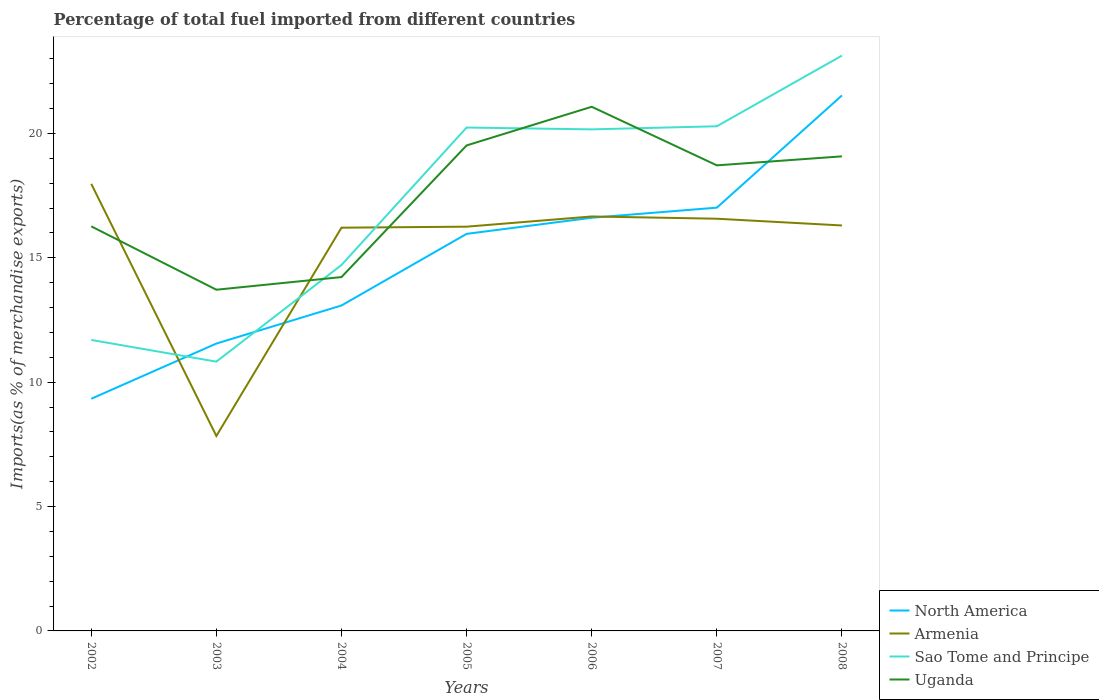How many different coloured lines are there?
Your response must be concise. 4. Does the line corresponding to Uganda intersect with the line corresponding to North America?
Offer a very short reply. Yes. Is the number of lines equal to the number of legend labels?
Ensure brevity in your answer.  Yes. Across all years, what is the maximum percentage of imports to different countries in Armenia?
Give a very brief answer. 7.84. What is the total percentage of imports to different countries in Uganda in the graph?
Provide a short and direct response. -1.55. What is the difference between the highest and the second highest percentage of imports to different countries in Armenia?
Provide a succinct answer. 10.14. What is the difference between the highest and the lowest percentage of imports to different countries in Uganda?
Your answer should be very brief. 4. Is the percentage of imports to different countries in Sao Tome and Principe strictly greater than the percentage of imports to different countries in Armenia over the years?
Offer a very short reply. No. How many lines are there?
Offer a very short reply. 4. How many years are there in the graph?
Keep it short and to the point. 7. Where does the legend appear in the graph?
Ensure brevity in your answer.  Bottom right. How are the legend labels stacked?
Ensure brevity in your answer.  Vertical. What is the title of the graph?
Your answer should be very brief. Percentage of total fuel imported from different countries. Does "Ethiopia" appear as one of the legend labels in the graph?
Your answer should be compact. No. What is the label or title of the Y-axis?
Provide a succinct answer. Imports(as % of merchandise exports). What is the Imports(as % of merchandise exports) in North America in 2002?
Provide a short and direct response. 9.33. What is the Imports(as % of merchandise exports) in Armenia in 2002?
Your response must be concise. 17.98. What is the Imports(as % of merchandise exports) in Sao Tome and Principe in 2002?
Ensure brevity in your answer.  11.7. What is the Imports(as % of merchandise exports) in Uganda in 2002?
Offer a terse response. 16.27. What is the Imports(as % of merchandise exports) in North America in 2003?
Offer a very short reply. 11.55. What is the Imports(as % of merchandise exports) of Armenia in 2003?
Your answer should be very brief. 7.84. What is the Imports(as % of merchandise exports) of Sao Tome and Principe in 2003?
Keep it short and to the point. 10.83. What is the Imports(as % of merchandise exports) in Uganda in 2003?
Offer a very short reply. 13.72. What is the Imports(as % of merchandise exports) in North America in 2004?
Provide a succinct answer. 13.08. What is the Imports(as % of merchandise exports) in Armenia in 2004?
Keep it short and to the point. 16.21. What is the Imports(as % of merchandise exports) of Sao Tome and Principe in 2004?
Make the answer very short. 14.71. What is the Imports(as % of merchandise exports) of Uganda in 2004?
Provide a short and direct response. 14.23. What is the Imports(as % of merchandise exports) of North America in 2005?
Keep it short and to the point. 15.96. What is the Imports(as % of merchandise exports) of Armenia in 2005?
Your answer should be compact. 16.25. What is the Imports(as % of merchandise exports) in Sao Tome and Principe in 2005?
Your response must be concise. 20.24. What is the Imports(as % of merchandise exports) of Uganda in 2005?
Your answer should be compact. 19.52. What is the Imports(as % of merchandise exports) of North America in 2006?
Give a very brief answer. 16.61. What is the Imports(as % of merchandise exports) of Armenia in 2006?
Offer a very short reply. 16.66. What is the Imports(as % of merchandise exports) in Sao Tome and Principe in 2006?
Your response must be concise. 20.17. What is the Imports(as % of merchandise exports) in Uganda in 2006?
Your answer should be compact. 21.07. What is the Imports(as % of merchandise exports) in North America in 2007?
Offer a terse response. 17.02. What is the Imports(as % of merchandise exports) in Armenia in 2007?
Keep it short and to the point. 16.57. What is the Imports(as % of merchandise exports) of Sao Tome and Principe in 2007?
Your answer should be compact. 20.29. What is the Imports(as % of merchandise exports) in Uganda in 2007?
Keep it short and to the point. 18.72. What is the Imports(as % of merchandise exports) in North America in 2008?
Make the answer very short. 21.53. What is the Imports(as % of merchandise exports) of Armenia in 2008?
Offer a very short reply. 16.3. What is the Imports(as % of merchandise exports) of Sao Tome and Principe in 2008?
Keep it short and to the point. 23.13. What is the Imports(as % of merchandise exports) in Uganda in 2008?
Give a very brief answer. 19.08. Across all years, what is the maximum Imports(as % of merchandise exports) of North America?
Keep it short and to the point. 21.53. Across all years, what is the maximum Imports(as % of merchandise exports) in Armenia?
Provide a succinct answer. 17.98. Across all years, what is the maximum Imports(as % of merchandise exports) of Sao Tome and Principe?
Offer a very short reply. 23.13. Across all years, what is the maximum Imports(as % of merchandise exports) in Uganda?
Make the answer very short. 21.07. Across all years, what is the minimum Imports(as % of merchandise exports) in North America?
Your answer should be compact. 9.33. Across all years, what is the minimum Imports(as % of merchandise exports) of Armenia?
Your answer should be compact. 7.84. Across all years, what is the minimum Imports(as % of merchandise exports) of Sao Tome and Principe?
Give a very brief answer. 10.83. Across all years, what is the minimum Imports(as % of merchandise exports) in Uganda?
Offer a terse response. 13.72. What is the total Imports(as % of merchandise exports) of North America in the graph?
Keep it short and to the point. 105.1. What is the total Imports(as % of merchandise exports) in Armenia in the graph?
Keep it short and to the point. 107.82. What is the total Imports(as % of merchandise exports) of Sao Tome and Principe in the graph?
Provide a succinct answer. 121.07. What is the total Imports(as % of merchandise exports) of Uganda in the graph?
Your answer should be very brief. 122.61. What is the difference between the Imports(as % of merchandise exports) of North America in 2002 and that in 2003?
Offer a very short reply. -2.22. What is the difference between the Imports(as % of merchandise exports) in Armenia in 2002 and that in 2003?
Provide a short and direct response. 10.14. What is the difference between the Imports(as % of merchandise exports) in Sao Tome and Principe in 2002 and that in 2003?
Keep it short and to the point. 0.87. What is the difference between the Imports(as % of merchandise exports) of Uganda in 2002 and that in 2003?
Provide a short and direct response. 2.55. What is the difference between the Imports(as % of merchandise exports) in North America in 2002 and that in 2004?
Make the answer very short. -3.75. What is the difference between the Imports(as % of merchandise exports) in Armenia in 2002 and that in 2004?
Your answer should be compact. 1.76. What is the difference between the Imports(as % of merchandise exports) in Sao Tome and Principe in 2002 and that in 2004?
Provide a succinct answer. -3.01. What is the difference between the Imports(as % of merchandise exports) of Uganda in 2002 and that in 2004?
Your answer should be very brief. 2.04. What is the difference between the Imports(as % of merchandise exports) of North America in 2002 and that in 2005?
Give a very brief answer. -6.63. What is the difference between the Imports(as % of merchandise exports) of Armenia in 2002 and that in 2005?
Give a very brief answer. 1.72. What is the difference between the Imports(as % of merchandise exports) of Sao Tome and Principe in 2002 and that in 2005?
Offer a very short reply. -8.54. What is the difference between the Imports(as % of merchandise exports) of Uganda in 2002 and that in 2005?
Your answer should be compact. -3.25. What is the difference between the Imports(as % of merchandise exports) in North America in 2002 and that in 2006?
Your response must be concise. -7.28. What is the difference between the Imports(as % of merchandise exports) in Armenia in 2002 and that in 2006?
Your response must be concise. 1.31. What is the difference between the Imports(as % of merchandise exports) in Sao Tome and Principe in 2002 and that in 2006?
Ensure brevity in your answer.  -8.47. What is the difference between the Imports(as % of merchandise exports) of Uganda in 2002 and that in 2006?
Give a very brief answer. -4.81. What is the difference between the Imports(as % of merchandise exports) in North America in 2002 and that in 2007?
Your answer should be compact. -7.68. What is the difference between the Imports(as % of merchandise exports) of Armenia in 2002 and that in 2007?
Keep it short and to the point. 1.4. What is the difference between the Imports(as % of merchandise exports) in Sao Tome and Principe in 2002 and that in 2007?
Offer a terse response. -8.59. What is the difference between the Imports(as % of merchandise exports) in Uganda in 2002 and that in 2007?
Your answer should be compact. -2.45. What is the difference between the Imports(as % of merchandise exports) of North America in 2002 and that in 2008?
Offer a very short reply. -12.2. What is the difference between the Imports(as % of merchandise exports) in Armenia in 2002 and that in 2008?
Offer a terse response. 1.67. What is the difference between the Imports(as % of merchandise exports) in Sao Tome and Principe in 2002 and that in 2008?
Keep it short and to the point. -11.43. What is the difference between the Imports(as % of merchandise exports) in Uganda in 2002 and that in 2008?
Your response must be concise. -2.81. What is the difference between the Imports(as % of merchandise exports) of North America in 2003 and that in 2004?
Offer a very short reply. -1.53. What is the difference between the Imports(as % of merchandise exports) of Armenia in 2003 and that in 2004?
Give a very brief answer. -8.37. What is the difference between the Imports(as % of merchandise exports) of Sao Tome and Principe in 2003 and that in 2004?
Give a very brief answer. -3.89. What is the difference between the Imports(as % of merchandise exports) in Uganda in 2003 and that in 2004?
Your answer should be compact. -0.51. What is the difference between the Imports(as % of merchandise exports) of North America in 2003 and that in 2005?
Provide a succinct answer. -4.41. What is the difference between the Imports(as % of merchandise exports) in Armenia in 2003 and that in 2005?
Give a very brief answer. -8.41. What is the difference between the Imports(as % of merchandise exports) in Sao Tome and Principe in 2003 and that in 2005?
Your response must be concise. -9.41. What is the difference between the Imports(as % of merchandise exports) of Uganda in 2003 and that in 2005?
Offer a very short reply. -5.8. What is the difference between the Imports(as % of merchandise exports) of North America in 2003 and that in 2006?
Provide a short and direct response. -5.06. What is the difference between the Imports(as % of merchandise exports) in Armenia in 2003 and that in 2006?
Your answer should be compact. -8.83. What is the difference between the Imports(as % of merchandise exports) of Sao Tome and Principe in 2003 and that in 2006?
Make the answer very short. -9.34. What is the difference between the Imports(as % of merchandise exports) of Uganda in 2003 and that in 2006?
Make the answer very short. -7.36. What is the difference between the Imports(as % of merchandise exports) in North America in 2003 and that in 2007?
Provide a succinct answer. -5.46. What is the difference between the Imports(as % of merchandise exports) in Armenia in 2003 and that in 2007?
Your answer should be compact. -8.73. What is the difference between the Imports(as % of merchandise exports) in Sao Tome and Principe in 2003 and that in 2007?
Ensure brevity in your answer.  -9.46. What is the difference between the Imports(as % of merchandise exports) of Uganda in 2003 and that in 2007?
Offer a terse response. -5. What is the difference between the Imports(as % of merchandise exports) of North America in 2003 and that in 2008?
Give a very brief answer. -9.98. What is the difference between the Imports(as % of merchandise exports) of Armenia in 2003 and that in 2008?
Provide a succinct answer. -8.46. What is the difference between the Imports(as % of merchandise exports) of Sao Tome and Principe in 2003 and that in 2008?
Your answer should be very brief. -12.31. What is the difference between the Imports(as % of merchandise exports) of Uganda in 2003 and that in 2008?
Provide a succinct answer. -5.36. What is the difference between the Imports(as % of merchandise exports) of North America in 2004 and that in 2005?
Keep it short and to the point. -2.88. What is the difference between the Imports(as % of merchandise exports) in Armenia in 2004 and that in 2005?
Ensure brevity in your answer.  -0.04. What is the difference between the Imports(as % of merchandise exports) in Sao Tome and Principe in 2004 and that in 2005?
Offer a terse response. -5.53. What is the difference between the Imports(as % of merchandise exports) in Uganda in 2004 and that in 2005?
Make the answer very short. -5.29. What is the difference between the Imports(as % of merchandise exports) of North America in 2004 and that in 2006?
Provide a succinct answer. -3.53. What is the difference between the Imports(as % of merchandise exports) of Armenia in 2004 and that in 2006?
Offer a terse response. -0.45. What is the difference between the Imports(as % of merchandise exports) of Sao Tome and Principe in 2004 and that in 2006?
Make the answer very short. -5.45. What is the difference between the Imports(as % of merchandise exports) of Uganda in 2004 and that in 2006?
Offer a very short reply. -6.85. What is the difference between the Imports(as % of merchandise exports) in North America in 2004 and that in 2007?
Provide a short and direct response. -3.93. What is the difference between the Imports(as % of merchandise exports) in Armenia in 2004 and that in 2007?
Keep it short and to the point. -0.36. What is the difference between the Imports(as % of merchandise exports) of Sao Tome and Principe in 2004 and that in 2007?
Keep it short and to the point. -5.58. What is the difference between the Imports(as % of merchandise exports) in Uganda in 2004 and that in 2007?
Your response must be concise. -4.49. What is the difference between the Imports(as % of merchandise exports) of North America in 2004 and that in 2008?
Give a very brief answer. -8.45. What is the difference between the Imports(as % of merchandise exports) in Armenia in 2004 and that in 2008?
Your answer should be compact. -0.09. What is the difference between the Imports(as % of merchandise exports) in Sao Tome and Principe in 2004 and that in 2008?
Provide a succinct answer. -8.42. What is the difference between the Imports(as % of merchandise exports) of Uganda in 2004 and that in 2008?
Give a very brief answer. -4.85. What is the difference between the Imports(as % of merchandise exports) of North America in 2005 and that in 2006?
Your answer should be very brief. -0.65. What is the difference between the Imports(as % of merchandise exports) of Armenia in 2005 and that in 2006?
Provide a short and direct response. -0.41. What is the difference between the Imports(as % of merchandise exports) of Sao Tome and Principe in 2005 and that in 2006?
Provide a short and direct response. 0.07. What is the difference between the Imports(as % of merchandise exports) in Uganda in 2005 and that in 2006?
Offer a very short reply. -1.55. What is the difference between the Imports(as % of merchandise exports) in North America in 2005 and that in 2007?
Make the answer very short. -1.05. What is the difference between the Imports(as % of merchandise exports) in Armenia in 2005 and that in 2007?
Your answer should be very brief. -0.32. What is the difference between the Imports(as % of merchandise exports) of Sao Tome and Principe in 2005 and that in 2007?
Provide a succinct answer. -0.05. What is the difference between the Imports(as % of merchandise exports) of Uganda in 2005 and that in 2007?
Provide a succinct answer. 0.8. What is the difference between the Imports(as % of merchandise exports) of North America in 2005 and that in 2008?
Give a very brief answer. -5.57. What is the difference between the Imports(as % of merchandise exports) in Armenia in 2005 and that in 2008?
Your answer should be very brief. -0.05. What is the difference between the Imports(as % of merchandise exports) in Sao Tome and Principe in 2005 and that in 2008?
Keep it short and to the point. -2.89. What is the difference between the Imports(as % of merchandise exports) in Uganda in 2005 and that in 2008?
Offer a terse response. 0.44. What is the difference between the Imports(as % of merchandise exports) of North America in 2006 and that in 2007?
Offer a very short reply. -0.41. What is the difference between the Imports(as % of merchandise exports) of Armenia in 2006 and that in 2007?
Provide a short and direct response. 0.09. What is the difference between the Imports(as % of merchandise exports) in Sao Tome and Principe in 2006 and that in 2007?
Your answer should be compact. -0.12. What is the difference between the Imports(as % of merchandise exports) of Uganda in 2006 and that in 2007?
Your answer should be very brief. 2.36. What is the difference between the Imports(as % of merchandise exports) in North America in 2006 and that in 2008?
Give a very brief answer. -4.92. What is the difference between the Imports(as % of merchandise exports) in Armenia in 2006 and that in 2008?
Provide a short and direct response. 0.36. What is the difference between the Imports(as % of merchandise exports) in Sao Tome and Principe in 2006 and that in 2008?
Give a very brief answer. -2.97. What is the difference between the Imports(as % of merchandise exports) of Uganda in 2006 and that in 2008?
Make the answer very short. 1.99. What is the difference between the Imports(as % of merchandise exports) of North America in 2007 and that in 2008?
Your answer should be very brief. -4.51. What is the difference between the Imports(as % of merchandise exports) of Armenia in 2007 and that in 2008?
Your answer should be compact. 0.27. What is the difference between the Imports(as % of merchandise exports) of Sao Tome and Principe in 2007 and that in 2008?
Ensure brevity in your answer.  -2.84. What is the difference between the Imports(as % of merchandise exports) of Uganda in 2007 and that in 2008?
Offer a terse response. -0.36. What is the difference between the Imports(as % of merchandise exports) of North America in 2002 and the Imports(as % of merchandise exports) of Armenia in 2003?
Provide a succinct answer. 1.5. What is the difference between the Imports(as % of merchandise exports) in North America in 2002 and the Imports(as % of merchandise exports) in Sao Tome and Principe in 2003?
Ensure brevity in your answer.  -1.49. What is the difference between the Imports(as % of merchandise exports) in North America in 2002 and the Imports(as % of merchandise exports) in Uganda in 2003?
Offer a terse response. -4.38. What is the difference between the Imports(as % of merchandise exports) of Armenia in 2002 and the Imports(as % of merchandise exports) of Sao Tome and Principe in 2003?
Offer a very short reply. 7.15. What is the difference between the Imports(as % of merchandise exports) in Armenia in 2002 and the Imports(as % of merchandise exports) in Uganda in 2003?
Make the answer very short. 4.26. What is the difference between the Imports(as % of merchandise exports) in Sao Tome and Principe in 2002 and the Imports(as % of merchandise exports) in Uganda in 2003?
Make the answer very short. -2.02. What is the difference between the Imports(as % of merchandise exports) in North America in 2002 and the Imports(as % of merchandise exports) in Armenia in 2004?
Make the answer very short. -6.88. What is the difference between the Imports(as % of merchandise exports) in North America in 2002 and the Imports(as % of merchandise exports) in Sao Tome and Principe in 2004?
Your response must be concise. -5.38. What is the difference between the Imports(as % of merchandise exports) of North America in 2002 and the Imports(as % of merchandise exports) of Uganda in 2004?
Provide a short and direct response. -4.89. What is the difference between the Imports(as % of merchandise exports) in Armenia in 2002 and the Imports(as % of merchandise exports) in Sao Tome and Principe in 2004?
Offer a very short reply. 3.26. What is the difference between the Imports(as % of merchandise exports) in Armenia in 2002 and the Imports(as % of merchandise exports) in Uganda in 2004?
Your answer should be very brief. 3.75. What is the difference between the Imports(as % of merchandise exports) in Sao Tome and Principe in 2002 and the Imports(as % of merchandise exports) in Uganda in 2004?
Keep it short and to the point. -2.53. What is the difference between the Imports(as % of merchandise exports) in North America in 2002 and the Imports(as % of merchandise exports) in Armenia in 2005?
Your answer should be compact. -6.92. What is the difference between the Imports(as % of merchandise exports) of North America in 2002 and the Imports(as % of merchandise exports) of Sao Tome and Principe in 2005?
Your response must be concise. -10.91. What is the difference between the Imports(as % of merchandise exports) of North America in 2002 and the Imports(as % of merchandise exports) of Uganda in 2005?
Offer a terse response. -10.19. What is the difference between the Imports(as % of merchandise exports) of Armenia in 2002 and the Imports(as % of merchandise exports) of Sao Tome and Principe in 2005?
Provide a short and direct response. -2.26. What is the difference between the Imports(as % of merchandise exports) in Armenia in 2002 and the Imports(as % of merchandise exports) in Uganda in 2005?
Ensure brevity in your answer.  -1.54. What is the difference between the Imports(as % of merchandise exports) of Sao Tome and Principe in 2002 and the Imports(as % of merchandise exports) of Uganda in 2005?
Provide a succinct answer. -7.82. What is the difference between the Imports(as % of merchandise exports) of North America in 2002 and the Imports(as % of merchandise exports) of Armenia in 2006?
Give a very brief answer. -7.33. What is the difference between the Imports(as % of merchandise exports) in North America in 2002 and the Imports(as % of merchandise exports) in Sao Tome and Principe in 2006?
Your answer should be compact. -10.83. What is the difference between the Imports(as % of merchandise exports) of North America in 2002 and the Imports(as % of merchandise exports) of Uganda in 2006?
Your answer should be compact. -11.74. What is the difference between the Imports(as % of merchandise exports) in Armenia in 2002 and the Imports(as % of merchandise exports) in Sao Tome and Principe in 2006?
Offer a very short reply. -2.19. What is the difference between the Imports(as % of merchandise exports) in Armenia in 2002 and the Imports(as % of merchandise exports) in Uganda in 2006?
Offer a very short reply. -3.1. What is the difference between the Imports(as % of merchandise exports) of Sao Tome and Principe in 2002 and the Imports(as % of merchandise exports) of Uganda in 2006?
Provide a short and direct response. -9.38. What is the difference between the Imports(as % of merchandise exports) in North America in 2002 and the Imports(as % of merchandise exports) in Armenia in 2007?
Keep it short and to the point. -7.24. What is the difference between the Imports(as % of merchandise exports) of North America in 2002 and the Imports(as % of merchandise exports) of Sao Tome and Principe in 2007?
Make the answer very short. -10.96. What is the difference between the Imports(as % of merchandise exports) of North America in 2002 and the Imports(as % of merchandise exports) of Uganda in 2007?
Your answer should be very brief. -9.38. What is the difference between the Imports(as % of merchandise exports) of Armenia in 2002 and the Imports(as % of merchandise exports) of Sao Tome and Principe in 2007?
Ensure brevity in your answer.  -2.32. What is the difference between the Imports(as % of merchandise exports) in Armenia in 2002 and the Imports(as % of merchandise exports) in Uganda in 2007?
Offer a terse response. -0.74. What is the difference between the Imports(as % of merchandise exports) in Sao Tome and Principe in 2002 and the Imports(as % of merchandise exports) in Uganda in 2007?
Ensure brevity in your answer.  -7.02. What is the difference between the Imports(as % of merchandise exports) in North America in 2002 and the Imports(as % of merchandise exports) in Armenia in 2008?
Keep it short and to the point. -6.97. What is the difference between the Imports(as % of merchandise exports) in North America in 2002 and the Imports(as % of merchandise exports) in Sao Tome and Principe in 2008?
Ensure brevity in your answer.  -13.8. What is the difference between the Imports(as % of merchandise exports) of North America in 2002 and the Imports(as % of merchandise exports) of Uganda in 2008?
Give a very brief answer. -9.75. What is the difference between the Imports(as % of merchandise exports) of Armenia in 2002 and the Imports(as % of merchandise exports) of Sao Tome and Principe in 2008?
Offer a terse response. -5.16. What is the difference between the Imports(as % of merchandise exports) of Armenia in 2002 and the Imports(as % of merchandise exports) of Uganda in 2008?
Make the answer very short. -1.11. What is the difference between the Imports(as % of merchandise exports) in Sao Tome and Principe in 2002 and the Imports(as % of merchandise exports) in Uganda in 2008?
Your answer should be very brief. -7.38. What is the difference between the Imports(as % of merchandise exports) of North America in 2003 and the Imports(as % of merchandise exports) of Armenia in 2004?
Provide a succinct answer. -4.66. What is the difference between the Imports(as % of merchandise exports) of North America in 2003 and the Imports(as % of merchandise exports) of Sao Tome and Principe in 2004?
Keep it short and to the point. -3.16. What is the difference between the Imports(as % of merchandise exports) of North America in 2003 and the Imports(as % of merchandise exports) of Uganda in 2004?
Make the answer very short. -2.67. What is the difference between the Imports(as % of merchandise exports) of Armenia in 2003 and the Imports(as % of merchandise exports) of Sao Tome and Principe in 2004?
Ensure brevity in your answer.  -6.87. What is the difference between the Imports(as % of merchandise exports) in Armenia in 2003 and the Imports(as % of merchandise exports) in Uganda in 2004?
Your response must be concise. -6.39. What is the difference between the Imports(as % of merchandise exports) in Sao Tome and Principe in 2003 and the Imports(as % of merchandise exports) in Uganda in 2004?
Your response must be concise. -3.4. What is the difference between the Imports(as % of merchandise exports) of North America in 2003 and the Imports(as % of merchandise exports) of Armenia in 2005?
Provide a short and direct response. -4.7. What is the difference between the Imports(as % of merchandise exports) in North America in 2003 and the Imports(as % of merchandise exports) in Sao Tome and Principe in 2005?
Offer a very short reply. -8.69. What is the difference between the Imports(as % of merchandise exports) of North America in 2003 and the Imports(as % of merchandise exports) of Uganda in 2005?
Ensure brevity in your answer.  -7.97. What is the difference between the Imports(as % of merchandise exports) of Armenia in 2003 and the Imports(as % of merchandise exports) of Sao Tome and Principe in 2005?
Ensure brevity in your answer.  -12.4. What is the difference between the Imports(as % of merchandise exports) of Armenia in 2003 and the Imports(as % of merchandise exports) of Uganda in 2005?
Your answer should be compact. -11.68. What is the difference between the Imports(as % of merchandise exports) of Sao Tome and Principe in 2003 and the Imports(as % of merchandise exports) of Uganda in 2005?
Your answer should be very brief. -8.69. What is the difference between the Imports(as % of merchandise exports) of North America in 2003 and the Imports(as % of merchandise exports) of Armenia in 2006?
Ensure brevity in your answer.  -5.11. What is the difference between the Imports(as % of merchandise exports) of North America in 2003 and the Imports(as % of merchandise exports) of Sao Tome and Principe in 2006?
Ensure brevity in your answer.  -8.61. What is the difference between the Imports(as % of merchandise exports) in North America in 2003 and the Imports(as % of merchandise exports) in Uganda in 2006?
Provide a succinct answer. -9.52. What is the difference between the Imports(as % of merchandise exports) in Armenia in 2003 and the Imports(as % of merchandise exports) in Sao Tome and Principe in 2006?
Provide a succinct answer. -12.33. What is the difference between the Imports(as % of merchandise exports) in Armenia in 2003 and the Imports(as % of merchandise exports) in Uganda in 2006?
Keep it short and to the point. -13.24. What is the difference between the Imports(as % of merchandise exports) of Sao Tome and Principe in 2003 and the Imports(as % of merchandise exports) of Uganda in 2006?
Make the answer very short. -10.25. What is the difference between the Imports(as % of merchandise exports) of North America in 2003 and the Imports(as % of merchandise exports) of Armenia in 2007?
Provide a succinct answer. -5.02. What is the difference between the Imports(as % of merchandise exports) of North America in 2003 and the Imports(as % of merchandise exports) of Sao Tome and Principe in 2007?
Ensure brevity in your answer.  -8.74. What is the difference between the Imports(as % of merchandise exports) in North America in 2003 and the Imports(as % of merchandise exports) in Uganda in 2007?
Keep it short and to the point. -7.17. What is the difference between the Imports(as % of merchandise exports) in Armenia in 2003 and the Imports(as % of merchandise exports) in Sao Tome and Principe in 2007?
Your response must be concise. -12.45. What is the difference between the Imports(as % of merchandise exports) of Armenia in 2003 and the Imports(as % of merchandise exports) of Uganda in 2007?
Provide a short and direct response. -10.88. What is the difference between the Imports(as % of merchandise exports) of Sao Tome and Principe in 2003 and the Imports(as % of merchandise exports) of Uganda in 2007?
Your answer should be compact. -7.89. What is the difference between the Imports(as % of merchandise exports) in North America in 2003 and the Imports(as % of merchandise exports) in Armenia in 2008?
Keep it short and to the point. -4.75. What is the difference between the Imports(as % of merchandise exports) in North America in 2003 and the Imports(as % of merchandise exports) in Sao Tome and Principe in 2008?
Your answer should be compact. -11.58. What is the difference between the Imports(as % of merchandise exports) of North America in 2003 and the Imports(as % of merchandise exports) of Uganda in 2008?
Ensure brevity in your answer.  -7.53. What is the difference between the Imports(as % of merchandise exports) of Armenia in 2003 and the Imports(as % of merchandise exports) of Sao Tome and Principe in 2008?
Offer a terse response. -15.29. What is the difference between the Imports(as % of merchandise exports) in Armenia in 2003 and the Imports(as % of merchandise exports) in Uganda in 2008?
Make the answer very short. -11.24. What is the difference between the Imports(as % of merchandise exports) of Sao Tome and Principe in 2003 and the Imports(as % of merchandise exports) of Uganda in 2008?
Offer a terse response. -8.25. What is the difference between the Imports(as % of merchandise exports) in North America in 2004 and the Imports(as % of merchandise exports) in Armenia in 2005?
Provide a short and direct response. -3.17. What is the difference between the Imports(as % of merchandise exports) of North America in 2004 and the Imports(as % of merchandise exports) of Sao Tome and Principe in 2005?
Provide a succinct answer. -7.16. What is the difference between the Imports(as % of merchandise exports) in North America in 2004 and the Imports(as % of merchandise exports) in Uganda in 2005?
Your answer should be very brief. -6.44. What is the difference between the Imports(as % of merchandise exports) in Armenia in 2004 and the Imports(as % of merchandise exports) in Sao Tome and Principe in 2005?
Offer a terse response. -4.03. What is the difference between the Imports(as % of merchandise exports) of Armenia in 2004 and the Imports(as % of merchandise exports) of Uganda in 2005?
Your answer should be compact. -3.31. What is the difference between the Imports(as % of merchandise exports) in Sao Tome and Principe in 2004 and the Imports(as % of merchandise exports) in Uganda in 2005?
Give a very brief answer. -4.81. What is the difference between the Imports(as % of merchandise exports) in North America in 2004 and the Imports(as % of merchandise exports) in Armenia in 2006?
Your response must be concise. -3.58. What is the difference between the Imports(as % of merchandise exports) of North America in 2004 and the Imports(as % of merchandise exports) of Sao Tome and Principe in 2006?
Make the answer very short. -7.08. What is the difference between the Imports(as % of merchandise exports) of North America in 2004 and the Imports(as % of merchandise exports) of Uganda in 2006?
Offer a very short reply. -7.99. What is the difference between the Imports(as % of merchandise exports) in Armenia in 2004 and the Imports(as % of merchandise exports) in Sao Tome and Principe in 2006?
Ensure brevity in your answer.  -3.95. What is the difference between the Imports(as % of merchandise exports) of Armenia in 2004 and the Imports(as % of merchandise exports) of Uganda in 2006?
Ensure brevity in your answer.  -4.86. What is the difference between the Imports(as % of merchandise exports) of Sao Tome and Principe in 2004 and the Imports(as % of merchandise exports) of Uganda in 2006?
Offer a terse response. -6.36. What is the difference between the Imports(as % of merchandise exports) in North America in 2004 and the Imports(as % of merchandise exports) in Armenia in 2007?
Provide a succinct answer. -3.49. What is the difference between the Imports(as % of merchandise exports) of North America in 2004 and the Imports(as % of merchandise exports) of Sao Tome and Principe in 2007?
Keep it short and to the point. -7.21. What is the difference between the Imports(as % of merchandise exports) of North America in 2004 and the Imports(as % of merchandise exports) of Uganda in 2007?
Make the answer very short. -5.63. What is the difference between the Imports(as % of merchandise exports) of Armenia in 2004 and the Imports(as % of merchandise exports) of Sao Tome and Principe in 2007?
Your answer should be very brief. -4.08. What is the difference between the Imports(as % of merchandise exports) of Armenia in 2004 and the Imports(as % of merchandise exports) of Uganda in 2007?
Your answer should be very brief. -2.51. What is the difference between the Imports(as % of merchandise exports) in Sao Tome and Principe in 2004 and the Imports(as % of merchandise exports) in Uganda in 2007?
Your response must be concise. -4.01. What is the difference between the Imports(as % of merchandise exports) of North America in 2004 and the Imports(as % of merchandise exports) of Armenia in 2008?
Offer a terse response. -3.22. What is the difference between the Imports(as % of merchandise exports) in North America in 2004 and the Imports(as % of merchandise exports) in Sao Tome and Principe in 2008?
Provide a short and direct response. -10.05. What is the difference between the Imports(as % of merchandise exports) of North America in 2004 and the Imports(as % of merchandise exports) of Uganda in 2008?
Your answer should be very brief. -6. What is the difference between the Imports(as % of merchandise exports) of Armenia in 2004 and the Imports(as % of merchandise exports) of Sao Tome and Principe in 2008?
Provide a short and direct response. -6.92. What is the difference between the Imports(as % of merchandise exports) in Armenia in 2004 and the Imports(as % of merchandise exports) in Uganda in 2008?
Your response must be concise. -2.87. What is the difference between the Imports(as % of merchandise exports) of Sao Tome and Principe in 2004 and the Imports(as % of merchandise exports) of Uganda in 2008?
Provide a succinct answer. -4.37. What is the difference between the Imports(as % of merchandise exports) in North America in 2005 and the Imports(as % of merchandise exports) in Armenia in 2006?
Your answer should be very brief. -0.7. What is the difference between the Imports(as % of merchandise exports) in North America in 2005 and the Imports(as % of merchandise exports) in Sao Tome and Principe in 2006?
Provide a short and direct response. -4.2. What is the difference between the Imports(as % of merchandise exports) of North America in 2005 and the Imports(as % of merchandise exports) of Uganda in 2006?
Offer a terse response. -5.11. What is the difference between the Imports(as % of merchandise exports) of Armenia in 2005 and the Imports(as % of merchandise exports) of Sao Tome and Principe in 2006?
Your answer should be compact. -3.91. What is the difference between the Imports(as % of merchandise exports) in Armenia in 2005 and the Imports(as % of merchandise exports) in Uganda in 2006?
Offer a very short reply. -4.82. What is the difference between the Imports(as % of merchandise exports) in Sao Tome and Principe in 2005 and the Imports(as % of merchandise exports) in Uganda in 2006?
Ensure brevity in your answer.  -0.83. What is the difference between the Imports(as % of merchandise exports) in North America in 2005 and the Imports(as % of merchandise exports) in Armenia in 2007?
Provide a succinct answer. -0.61. What is the difference between the Imports(as % of merchandise exports) in North America in 2005 and the Imports(as % of merchandise exports) in Sao Tome and Principe in 2007?
Provide a succinct answer. -4.33. What is the difference between the Imports(as % of merchandise exports) of North America in 2005 and the Imports(as % of merchandise exports) of Uganda in 2007?
Your response must be concise. -2.75. What is the difference between the Imports(as % of merchandise exports) in Armenia in 2005 and the Imports(as % of merchandise exports) in Sao Tome and Principe in 2007?
Give a very brief answer. -4.04. What is the difference between the Imports(as % of merchandise exports) in Armenia in 2005 and the Imports(as % of merchandise exports) in Uganda in 2007?
Keep it short and to the point. -2.47. What is the difference between the Imports(as % of merchandise exports) of Sao Tome and Principe in 2005 and the Imports(as % of merchandise exports) of Uganda in 2007?
Provide a succinct answer. 1.52. What is the difference between the Imports(as % of merchandise exports) of North America in 2005 and the Imports(as % of merchandise exports) of Armenia in 2008?
Make the answer very short. -0.34. What is the difference between the Imports(as % of merchandise exports) of North America in 2005 and the Imports(as % of merchandise exports) of Sao Tome and Principe in 2008?
Offer a very short reply. -7.17. What is the difference between the Imports(as % of merchandise exports) in North America in 2005 and the Imports(as % of merchandise exports) in Uganda in 2008?
Your response must be concise. -3.12. What is the difference between the Imports(as % of merchandise exports) in Armenia in 2005 and the Imports(as % of merchandise exports) in Sao Tome and Principe in 2008?
Keep it short and to the point. -6.88. What is the difference between the Imports(as % of merchandise exports) of Armenia in 2005 and the Imports(as % of merchandise exports) of Uganda in 2008?
Offer a terse response. -2.83. What is the difference between the Imports(as % of merchandise exports) in Sao Tome and Principe in 2005 and the Imports(as % of merchandise exports) in Uganda in 2008?
Offer a very short reply. 1.16. What is the difference between the Imports(as % of merchandise exports) in North America in 2006 and the Imports(as % of merchandise exports) in Armenia in 2007?
Your response must be concise. 0.04. What is the difference between the Imports(as % of merchandise exports) of North America in 2006 and the Imports(as % of merchandise exports) of Sao Tome and Principe in 2007?
Offer a very short reply. -3.68. What is the difference between the Imports(as % of merchandise exports) in North America in 2006 and the Imports(as % of merchandise exports) in Uganda in 2007?
Ensure brevity in your answer.  -2.11. What is the difference between the Imports(as % of merchandise exports) in Armenia in 2006 and the Imports(as % of merchandise exports) in Sao Tome and Principe in 2007?
Offer a terse response. -3.63. What is the difference between the Imports(as % of merchandise exports) in Armenia in 2006 and the Imports(as % of merchandise exports) in Uganda in 2007?
Your answer should be compact. -2.06. What is the difference between the Imports(as % of merchandise exports) in Sao Tome and Principe in 2006 and the Imports(as % of merchandise exports) in Uganda in 2007?
Give a very brief answer. 1.45. What is the difference between the Imports(as % of merchandise exports) in North America in 2006 and the Imports(as % of merchandise exports) in Armenia in 2008?
Keep it short and to the point. 0.31. What is the difference between the Imports(as % of merchandise exports) of North America in 2006 and the Imports(as % of merchandise exports) of Sao Tome and Principe in 2008?
Your answer should be compact. -6.52. What is the difference between the Imports(as % of merchandise exports) of North America in 2006 and the Imports(as % of merchandise exports) of Uganda in 2008?
Ensure brevity in your answer.  -2.47. What is the difference between the Imports(as % of merchandise exports) in Armenia in 2006 and the Imports(as % of merchandise exports) in Sao Tome and Principe in 2008?
Keep it short and to the point. -6.47. What is the difference between the Imports(as % of merchandise exports) in Armenia in 2006 and the Imports(as % of merchandise exports) in Uganda in 2008?
Give a very brief answer. -2.42. What is the difference between the Imports(as % of merchandise exports) in Sao Tome and Principe in 2006 and the Imports(as % of merchandise exports) in Uganda in 2008?
Give a very brief answer. 1.08. What is the difference between the Imports(as % of merchandise exports) in North America in 2007 and the Imports(as % of merchandise exports) in Armenia in 2008?
Offer a very short reply. 0.72. What is the difference between the Imports(as % of merchandise exports) in North America in 2007 and the Imports(as % of merchandise exports) in Sao Tome and Principe in 2008?
Offer a very short reply. -6.11. What is the difference between the Imports(as % of merchandise exports) in North America in 2007 and the Imports(as % of merchandise exports) in Uganda in 2008?
Keep it short and to the point. -2.06. What is the difference between the Imports(as % of merchandise exports) of Armenia in 2007 and the Imports(as % of merchandise exports) of Sao Tome and Principe in 2008?
Offer a very short reply. -6.56. What is the difference between the Imports(as % of merchandise exports) of Armenia in 2007 and the Imports(as % of merchandise exports) of Uganda in 2008?
Offer a very short reply. -2.51. What is the difference between the Imports(as % of merchandise exports) in Sao Tome and Principe in 2007 and the Imports(as % of merchandise exports) in Uganda in 2008?
Make the answer very short. 1.21. What is the average Imports(as % of merchandise exports) in North America per year?
Provide a short and direct response. 15.01. What is the average Imports(as % of merchandise exports) of Armenia per year?
Give a very brief answer. 15.4. What is the average Imports(as % of merchandise exports) of Sao Tome and Principe per year?
Provide a succinct answer. 17.3. What is the average Imports(as % of merchandise exports) of Uganda per year?
Make the answer very short. 17.52. In the year 2002, what is the difference between the Imports(as % of merchandise exports) of North America and Imports(as % of merchandise exports) of Armenia?
Provide a succinct answer. -8.64. In the year 2002, what is the difference between the Imports(as % of merchandise exports) in North America and Imports(as % of merchandise exports) in Sao Tome and Principe?
Make the answer very short. -2.36. In the year 2002, what is the difference between the Imports(as % of merchandise exports) in North America and Imports(as % of merchandise exports) in Uganda?
Your answer should be very brief. -6.93. In the year 2002, what is the difference between the Imports(as % of merchandise exports) in Armenia and Imports(as % of merchandise exports) in Sao Tome and Principe?
Make the answer very short. 6.28. In the year 2002, what is the difference between the Imports(as % of merchandise exports) of Armenia and Imports(as % of merchandise exports) of Uganda?
Your answer should be very brief. 1.71. In the year 2002, what is the difference between the Imports(as % of merchandise exports) in Sao Tome and Principe and Imports(as % of merchandise exports) in Uganda?
Provide a succinct answer. -4.57. In the year 2003, what is the difference between the Imports(as % of merchandise exports) in North America and Imports(as % of merchandise exports) in Armenia?
Ensure brevity in your answer.  3.72. In the year 2003, what is the difference between the Imports(as % of merchandise exports) of North America and Imports(as % of merchandise exports) of Sao Tome and Principe?
Your response must be concise. 0.73. In the year 2003, what is the difference between the Imports(as % of merchandise exports) of North America and Imports(as % of merchandise exports) of Uganda?
Provide a succinct answer. -2.16. In the year 2003, what is the difference between the Imports(as % of merchandise exports) in Armenia and Imports(as % of merchandise exports) in Sao Tome and Principe?
Ensure brevity in your answer.  -2.99. In the year 2003, what is the difference between the Imports(as % of merchandise exports) of Armenia and Imports(as % of merchandise exports) of Uganda?
Offer a terse response. -5.88. In the year 2003, what is the difference between the Imports(as % of merchandise exports) in Sao Tome and Principe and Imports(as % of merchandise exports) in Uganda?
Offer a terse response. -2.89. In the year 2004, what is the difference between the Imports(as % of merchandise exports) in North America and Imports(as % of merchandise exports) in Armenia?
Your response must be concise. -3.13. In the year 2004, what is the difference between the Imports(as % of merchandise exports) in North America and Imports(as % of merchandise exports) in Sao Tome and Principe?
Your response must be concise. -1.63. In the year 2004, what is the difference between the Imports(as % of merchandise exports) of North America and Imports(as % of merchandise exports) of Uganda?
Offer a very short reply. -1.14. In the year 2004, what is the difference between the Imports(as % of merchandise exports) of Armenia and Imports(as % of merchandise exports) of Sao Tome and Principe?
Offer a terse response. 1.5. In the year 2004, what is the difference between the Imports(as % of merchandise exports) in Armenia and Imports(as % of merchandise exports) in Uganda?
Offer a terse response. 1.99. In the year 2004, what is the difference between the Imports(as % of merchandise exports) of Sao Tome and Principe and Imports(as % of merchandise exports) of Uganda?
Make the answer very short. 0.49. In the year 2005, what is the difference between the Imports(as % of merchandise exports) in North America and Imports(as % of merchandise exports) in Armenia?
Provide a short and direct response. -0.29. In the year 2005, what is the difference between the Imports(as % of merchandise exports) in North America and Imports(as % of merchandise exports) in Sao Tome and Principe?
Ensure brevity in your answer.  -4.28. In the year 2005, what is the difference between the Imports(as % of merchandise exports) of North America and Imports(as % of merchandise exports) of Uganda?
Your response must be concise. -3.56. In the year 2005, what is the difference between the Imports(as % of merchandise exports) in Armenia and Imports(as % of merchandise exports) in Sao Tome and Principe?
Make the answer very short. -3.99. In the year 2005, what is the difference between the Imports(as % of merchandise exports) of Armenia and Imports(as % of merchandise exports) of Uganda?
Provide a short and direct response. -3.27. In the year 2005, what is the difference between the Imports(as % of merchandise exports) of Sao Tome and Principe and Imports(as % of merchandise exports) of Uganda?
Offer a very short reply. 0.72. In the year 2006, what is the difference between the Imports(as % of merchandise exports) of North America and Imports(as % of merchandise exports) of Armenia?
Make the answer very short. -0.05. In the year 2006, what is the difference between the Imports(as % of merchandise exports) of North America and Imports(as % of merchandise exports) of Sao Tome and Principe?
Your answer should be very brief. -3.55. In the year 2006, what is the difference between the Imports(as % of merchandise exports) in North America and Imports(as % of merchandise exports) in Uganda?
Make the answer very short. -4.46. In the year 2006, what is the difference between the Imports(as % of merchandise exports) in Armenia and Imports(as % of merchandise exports) in Sao Tome and Principe?
Provide a short and direct response. -3.5. In the year 2006, what is the difference between the Imports(as % of merchandise exports) of Armenia and Imports(as % of merchandise exports) of Uganda?
Provide a short and direct response. -4.41. In the year 2006, what is the difference between the Imports(as % of merchandise exports) in Sao Tome and Principe and Imports(as % of merchandise exports) in Uganda?
Your answer should be compact. -0.91. In the year 2007, what is the difference between the Imports(as % of merchandise exports) in North America and Imports(as % of merchandise exports) in Armenia?
Make the answer very short. 0.45. In the year 2007, what is the difference between the Imports(as % of merchandise exports) in North America and Imports(as % of merchandise exports) in Sao Tome and Principe?
Your answer should be very brief. -3.27. In the year 2007, what is the difference between the Imports(as % of merchandise exports) in North America and Imports(as % of merchandise exports) in Uganda?
Your answer should be very brief. -1.7. In the year 2007, what is the difference between the Imports(as % of merchandise exports) of Armenia and Imports(as % of merchandise exports) of Sao Tome and Principe?
Ensure brevity in your answer.  -3.72. In the year 2007, what is the difference between the Imports(as % of merchandise exports) in Armenia and Imports(as % of merchandise exports) in Uganda?
Offer a terse response. -2.15. In the year 2007, what is the difference between the Imports(as % of merchandise exports) in Sao Tome and Principe and Imports(as % of merchandise exports) in Uganda?
Provide a succinct answer. 1.57. In the year 2008, what is the difference between the Imports(as % of merchandise exports) of North America and Imports(as % of merchandise exports) of Armenia?
Keep it short and to the point. 5.23. In the year 2008, what is the difference between the Imports(as % of merchandise exports) of North America and Imports(as % of merchandise exports) of Sao Tome and Principe?
Your answer should be compact. -1.6. In the year 2008, what is the difference between the Imports(as % of merchandise exports) in North America and Imports(as % of merchandise exports) in Uganda?
Your answer should be compact. 2.45. In the year 2008, what is the difference between the Imports(as % of merchandise exports) in Armenia and Imports(as % of merchandise exports) in Sao Tome and Principe?
Make the answer very short. -6.83. In the year 2008, what is the difference between the Imports(as % of merchandise exports) of Armenia and Imports(as % of merchandise exports) of Uganda?
Offer a terse response. -2.78. In the year 2008, what is the difference between the Imports(as % of merchandise exports) of Sao Tome and Principe and Imports(as % of merchandise exports) of Uganda?
Your answer should be compact. 4.05. What is the ratio of the Imports(as % of merchandise exports) in North America in 2002 to that in 2003?
Your answer should be very brief. 0.81. What is the ratio of the Imports(as % of merchandise exports) in Armenia in 2002 to that in 2003?
Keep it short and to the point. 2.29. What is the ratio of the Imports(as % of merchandise exports) in Sao Tome and Principe in 2002 to that in 2003?
Ensure brevity in your answer.  1.08. What is the ratio of the Imports(as % of merchandise exports) of Uganda in 2002 to that in 2003?
Offer a terse response. 1.19. What is the ratio of the Imports(as % of merchandise exports) of North America in 2002 to that in 2004?
Your answer should be compact. 0.71. What is the ratio of the Imports(as % of merchandise exports) of Armenia in 2002 to that in 2004?
Provide a short and direct response. 1.11. What is the ratio of the Imports(as % of merchandise exports) of Sao Tome and Principe in 2002 to that in 2004?
Offer a terse response. 0.8. What is the ratio of the Imports(as % of merchandise exports) of Uganda in 2002 to that in 2004?
Give a very brief answer. 1.14. What is the ratio of the Imports(as % of merchandise exports) of North America in 2002 to that in 2005?
Your answer should be compact. 0.58. What is the ratio of the Imports(as % of merchandise exports) in Armenia in 2002 to that in 2005?
Ensure brevity in your answer.  1.11. What is the ratio of the Imports(as % of merchandise exports) in Sao Tome and Principe in 2002 to that in 2005?
Offer a terse response. 0.58. What is the ratio of the Imports(as % of merchandise exports) in Uganda in 2002 to that in 2005?
Make the answer very short. 0.83. What is the ratio of the Imports(as % of merchandise exports) in North America in 2002 to that in 2006?
Make the answer very short. 0.56. What is the ratio of the Imports(as % of merchandise exports) of Armenia in 2002 to that in 2006?
Your answer should be very brief. 1.08. What is the ratio of the Imports(as % of merchandise exports) in Sao Tome and Principe in 2002 to that in 2006?
Keep it short and to the point. 0.58. What is the ratio of the Imports(as % of merchandise exports) of Uganda in 2002 to that in 2006?
Give a very brief answer. 0.77. What is the ratio of the Imports(as % of merchandise exports) in North America in 2002 to that in 2007?
Your answer should be very brief. 0.55. What is the ratio of the Imports(as % of merchandise exports) of Armenia in 2002 to that in 2007?
Keep it short and to the point. 1.08. What is the ratio of the Imports(as % of merchandise exports) of Sao Tome and Principe in 2002 to that in 2007?
Your response must be concise. 0.58. What is the ratio of the Imports(as % of merchandise exports) of Uganda in 2002 to that in 2007?
Give a very brief answer. 0.87. What is the ratio of the Imports(as % of merchandise exports) in North America in 2002 to that in 2008?
Your answer should be compact. 0.43. What is the ratio of the Imports(as % of merchandise exports) in Armenia in 2002 to that in 2008?
Ensure brevity in your answer.  1.1. What is the ratio of the Imports(as % of merchandise exports) of Sao Tome and Principe in 2002 to that in 2008?
Offer a terse response. 0.51. What is the ratio of the Imports(as % of merchandise exports) of Uganda in 2002 to that in 2008?
Provide a short and direct response. 0.85. What is the ratio of the Imports(as % of merchandise exports) in North America in 2003 to that in 2004?
Your response must be concise. 0.88. What is the ratio of the Imports(as % of merchandise exports) of Armenia in 2003 to that in 2004?
Offer a very short reply. 0.48. What is the ratio of the Imports(as % of merchandise exports) of Sao Tome and Principe in 2003 to that in 2004?
Offer a terse response. 0.74. What is the ratio of the Imports(as % of merchandise exports) of Uganda in 2003 to that in 2004?
Your answer should be very brief. 0.96. What is the ratio of the Imports(as % of merchandise exports) in North America in 2003 to that in 2005?
Provide a short and direct response. 0.72. What is the ratio of the Imports(as % of merchandise exports) of Armenia in 2003 to that in 2005?
Your answer should be compact. 0.48. What is the ratio of the Imports(as % of merchandise exports) in Sao Tome and Principe in 2003 to that in 2005?
Your answer should be compact. 0.53. What is the ratio of the Imports(as % of merchandise exports) in Uganda in 2003 to that in 2005?
Your answer should be compact. 0.7. What is the ratio of the Imports(as % of merchandise exports) of North America in 2003 to that in 2006?
Give a very brief answer. 0.7. What is the ratio of the Imports(as % of merchandise exports) in Armenia in 2003 to that in 2006?
Offer a terse response. 0.47. What is the ratio of the Imports(as % of merchandise exports) in Sao Tome and Principe in 2003 to that in 2006?
Offer a very short reply. 0.54. What is the ratio of the Imports(as % of merchandise exports) of Uganda in 2003 to that in 2006?
Your answer should be compact. 0.65. What is the ratio of the Imports(as % of merchandise exports) in North America in 2003 to that in 2007?
Provide a succinct answer. 0.68. What is the ratio of the Imports(as % of merchandise exports) in Armenia in 2003 to that in 2007?
Give a very brief answer. 0.47. What is the ratio of the Imports(as % of merchandise exports) of Sao Tome and Principe in 2003 to that in 2007?
Provide a short and direct response. 0.53. What is the ratio of the Imports(as % of merchandise exports) in Uganda in 2003 to that in 2007?
Ensure brevity in your answer.  0.73. What is the ratio of the Imports(as % of merchandise exports) of North America in 2003 to that in 2008?
Ensure brevity in your answer.  0.54. What is the ratio of the Imports(as % of merchandise exports) in Armenia in 2003 to that in 2008?
Keep it short and to the point. 0.48. What is the ratio of the Imports(as % of merchandise exports) of Sao Tome and Principe in 2003 to that in 2008?
Provide a short and direct response. 0.47. What is the ratio of the Imports(as % of merchandise exports) of Uganda in 2003 to that in 2008?
Provide a succinct answer. 0.72. What is the ratio of the Imports(as % of merchandise exports) of North America in 2004 to that in 2005?
Your response must be concise. 0.82. What is the ratio of the Imports(as % of merchandise exports) in Sao Tome and Principe in 2004 to that in 2005?
Ensure brevity in your answer.  0.73. What is the ratio of the Imports(as % of merchandise exports) in Uganda in 2004 to that in 2005?
Your answer should be very brief. 0.73. What is the ratio of the Imports(as % of merchandise exports) in North America in 2004 to that in 2006?
Make the answer very short. 0.79. What is the ratio of the Imports(as % of merchandise exports) in Armenia in 2004 to that in 2006?
Provide a short and direct response. 0.97. What is the ratio of the Imports(as % of merchandise exports) of Sao Tome and Principe in 2004 to that in 2006?
Give a very brief answer. 0.73. What is the ratio of the Imports(as % of merchandise exports) of Uganda in 2004 to that in 2006?
Your answer should be very brief. 0.68. What is the ratio of the Imports(as % of merchandise exports) in North America in 2004 to that in 2007?
Give a very brief answer. 0.77. What is the ratio of the Imports(as % of merchandise exports) in Armenia in 2004 to that in 2007?
Your answer should be very brief. 0.98. What is the ratio of the Imports(as % of merchandise exports) of Sao Tome and Principe in 2004 to that in 2007?
Offer a terse response. 0.73. What is the ratio of the Imports(as % of merchandise exports) in Uganda in 2004 to that in 2007?
Your answer should be very brief. 0.76. What is the ratio of the Imports(as % of merchandise exports) in North America in 2004 to that in 2008?
Ensure brevity in your answer.  0.61. What is the ratio of the Imports(as % of merchandise exports) in Armenia in 2004 to that in 2008?
Keep it short and to the point. 0.99. What is the ratio of the Imports(as % of merchandise exports) of Sao Tome and Principe in 2004 to that in 2008?
Your response must be concise. 0.64. What is the ratio of the Imports(as % of merchandise exports) of Uganda in 2004 to that in 2008?
Provide a short and direct response. 0.75. What is the ratio of the Imports(as % of merchandise exports) in Armenia in 2005 to that in 2006?
Make the answer very short. 0.98. What is the ratio of the Imports(as % of merchandise exports) in Sao Tome and Principe in 2005 to that in 2006?
Give a very brief answer. 1. What is the ratio of the Imports(as % of merchandise exports) of Uganda in 2005 to that in 2006?
Give a very brief answer. 0.93. What is the ratio of the Imports(as % of merchandise exports) in North America in 2005 to that in 2007?
Give a very brief answer. 0.94. What is the ratio of the Imports(as % of merchandise exports) in Armenia in 2005 to that in 2007?
Give a very brief answer. 0.98. What is the ratio of the Imports(as % of merchandise exports) in Sao Tome and Principe in 2005 to that in 2007?
Give a very brief answer. 1. What is the ratio of the Imports(as % of merchandise exports) in Uganda in 2005 to that in 2007?
Offer a terse response. 1.04. What is the ratio of the Imports(as % of merchandise exports) in North America in 2005 to that in 2008?
Make the answer very short. 0.74. What is the ratio of the Imports(as % of merchandise exports) of Sao Tome and Principe in 2005 to that in 2008?
Keep it short and to the point. 0.88. What is the ratio of the Imports(as % of merchandise exports) in North America in 2006 to that in 2007?
Keep it short and to the point. 0.98. What is the ratio of the Imports(as % of merchandise exports) in Sao Tome and Principe in 2006 to that in 2007?
Your answer should be very brief. 0.99. What is the ratio of the Imports(as % of merchandise exports) in Uganda in 2006 to that in 2007?
Your response must be concise. 1.13. What is the ratio of the Imports(as % of merchandise exports) in North America in 2006 to that in 2008?
Your response must be concise. 0.77. What is the ratio of the Imports(as % of merchandise exports) in Armenia in 2006 to that in 2008?
Make the answer very short. 1.02. What is the ratio of the Imports(as % of merchandise exports) in Sao Tome and Principe in 2006 to that in 2008?
Your response must be concise. 0.87. What is the ratio of the Imports(as % of merchandise exports) of Uganda in 2006 to that in 2008?
Provide a succinct answer. 1.1. What is the ratio of the Imports(as % of merchandise exports) in North America in 2007 to that in 2008?
Offer a terse response. 0.79. What is the ratio of the Imports(as % of merchandise exports) in Armenia in 2007 to that in 2008?
Your answer should be very brief. 1.02. What is the ratio of the Imports(as % of merchandise exports) in Sao Tome and Principe in 2007 to that in 2008?
Your answer should be compact. 0.88. What is the ratio of the Imports(as % of merchandise exports) of Uganda in 2007 to that in 2008?
Offer a terse response. 0.98. What is the difference between the highest and the second highest Imports(as % of merchandise exports) in North America?
Make the answer very short. 4.51. What is the difference between the highest and the second highest Imports(as % of merchandise exports) of Armenia?
Make the answer very short. 1.31. What is the difference between the highest and the second highest Imports(as % of merchandise exports) in Sao Tome and Principe?
Provide a succinct answer. 2.84. What is the difference between the highest and the second highest Imports(as % of merchandise exports) in Uganda?
Your response must be concise. 1.55. What is the difference between the highest and the lowest Imports(as % of merchandise exports) in North America?
Give a very brief answer. 12.2. What is the difference between the highest and the lowest Imports(as % of merchandise exports) of Armenia?
Ensure brevity in your answer.  10.14. What is the difference between the highest and the lowest Imports(as % of merchandise exports) in Sao Tome and Principe?
Ensure brevity in your answer.  12.31. What is the difference between the highest and the lowest Imports(as % of merchandise exports) of Uganda?
Your answer should be very brief. 7.36. 